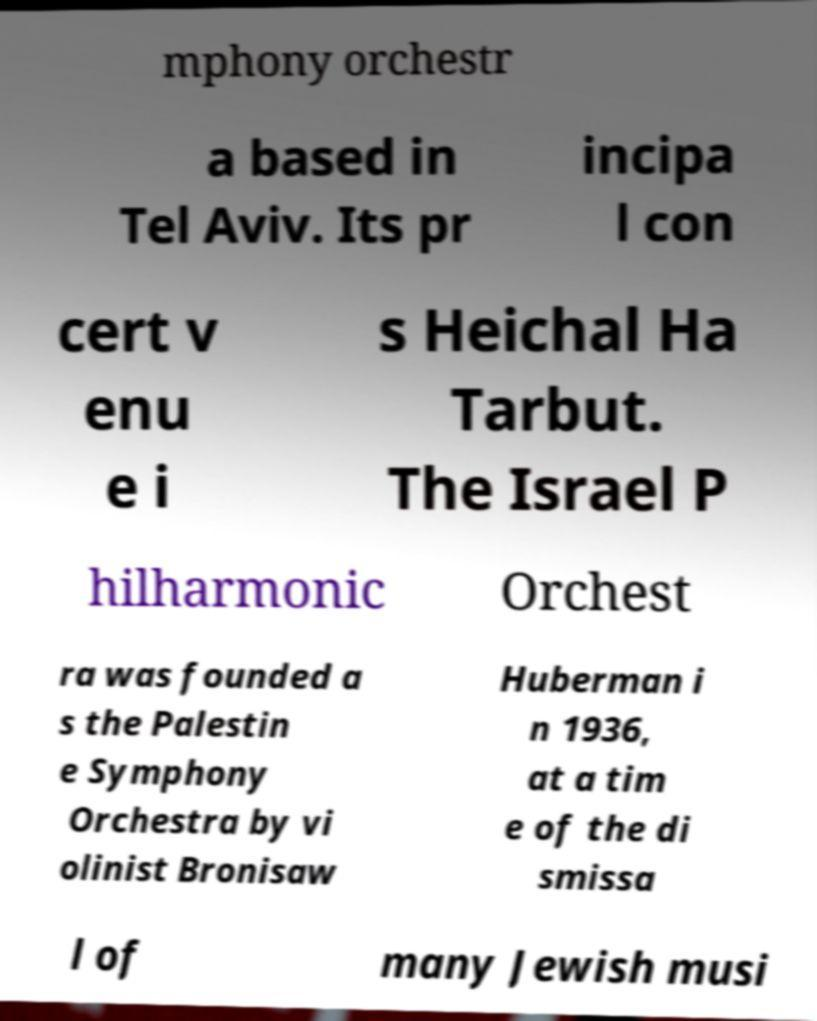For documentation purposes, I need the text within this image transcribed. Could you provide that? mphony orchestr a based in Tel Aviv. Its pr incipa l con cert v enu e i s Heichal Ha Tarbut. The Israel P hilharmonic Orchest ra was founded a s the Palestin e Symphony Orchestra by vi olinist Bronisaw Huberman i n 1936, at a tim e of the di smissa l of many Jewish musi 